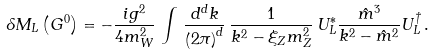Convert formula to latex. <formula><loc_0><loc_0><loc_500><loc_500>\delta M _ { L } \left ( G ^ { 0 } \right ) = - \frac { i g ^ { 2 } } { 4 m _ { W } ^ { 2 } } \, \int \, \frac { d ^ { d } k } { \left ( 2 \pi \right ) ^ { d } } \, \frac { 1 } { k ^ { 2 } - \xi _ { Z } m _ { Z } ^ { 2 } } \, U _ { L } ^ { \ast } \frac { \hat { m } ^ { 3 } } { k ^ { 2 } - \hat { m } ^ { 2 } } U _ { L } ^ { \dagger } \, .</formula> 